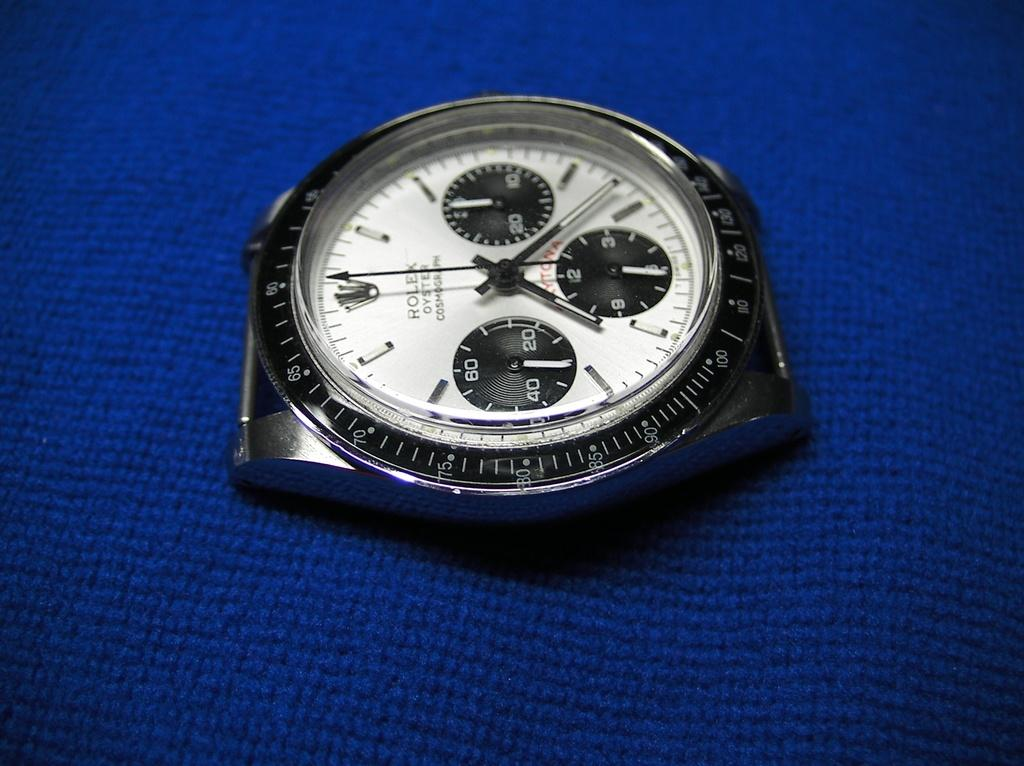Provide a one-sentence caption for the provided image. Face of a watch which has the word ROLEX on it. 